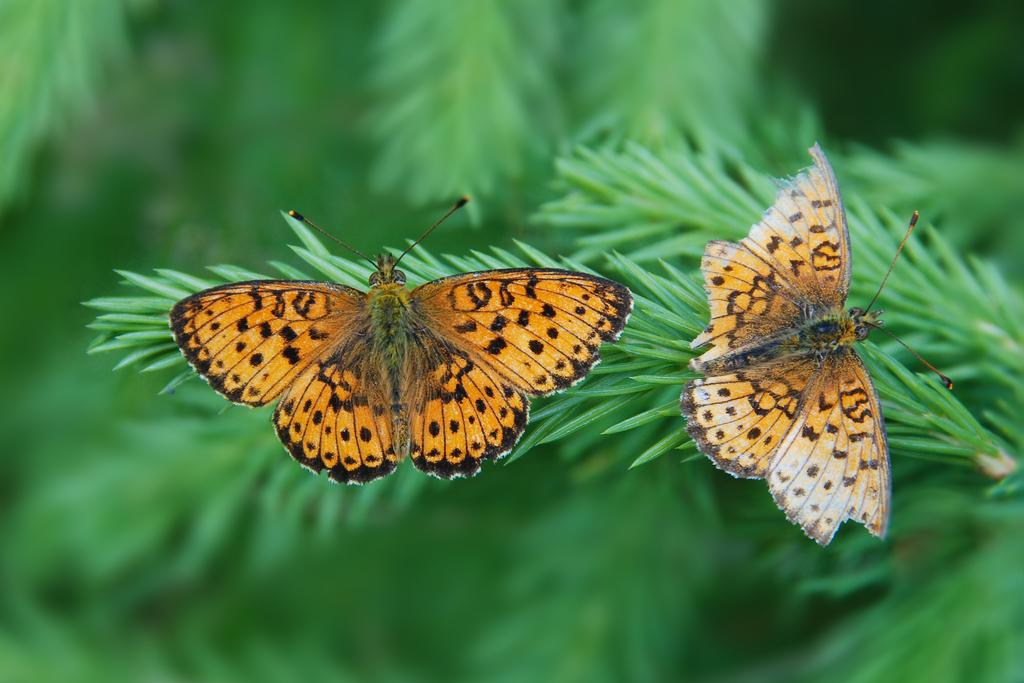How many butterflies are present in the image? There are two butterflies in the image. Where are the butterflies located? The butterflies are on leaves. What can be observed about the background of the image? The background of the image appears green and blurry. What type of record is being played by the butterflies in the image? There is no record present in the image, and the butterflies are not interacting with any musical equipment. 